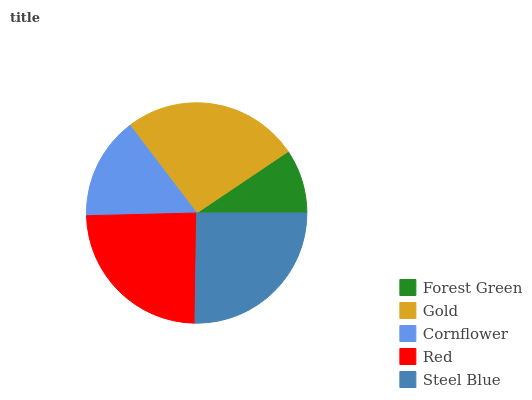Is Forest Green the minimum?
Answer yes or no. Yes. Is Gold the maximum?
Answer yes or no. Yes. Is Cornflower the minimum?
Answer yes or no. No. Is Cornflower the maximum?
Answer yes or no. No. Is Gold greater than Cornflower?
Answer yes or no. Yes. Is Cornflower less than Gold?
Answer yes or no. Yes. Is Cornflower greater than Gold?
Answer yes or no. No. Is Gold less than Cornflower?
Answer yes or no. No. Is Red the high median?
Answer yes or no. Yes. Is Red the low median?
Answer yes or no. Yes. Is Forest Green the high median?
Answer yes or no. No. Is Steel Blue the low median?
Answer yes or no. No. 